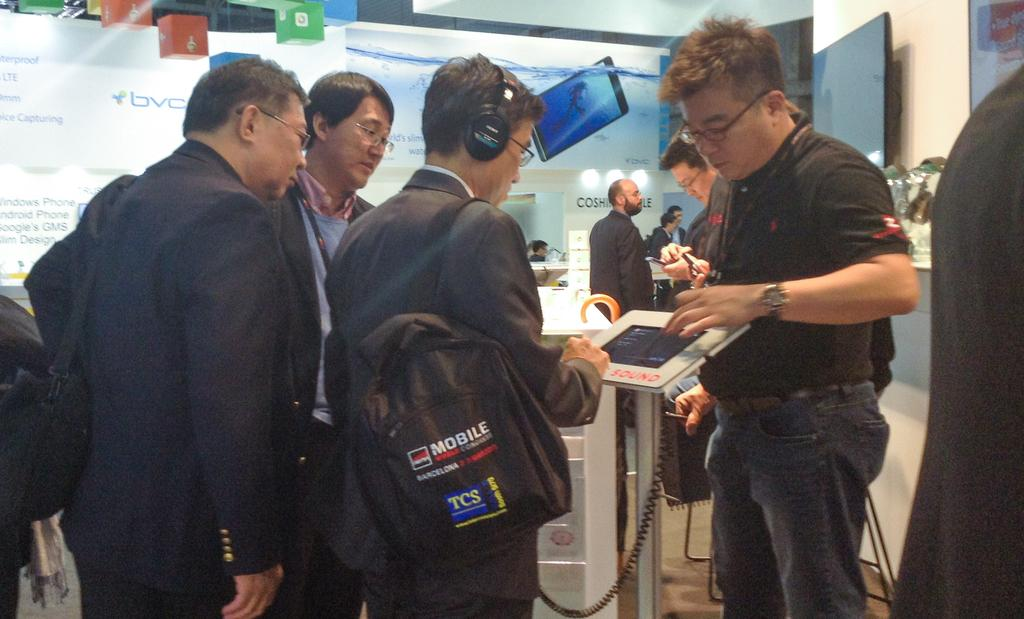What can be observed about the people in the image? There are people standing in the image. What are some people wearing in the image? Some people are wearing bags in the image. What objects can be seen in the image besides people? There are boards, banners, and a screen in the image. What is the background of the image like? There is a white wall in the image. Can you tell me how many arches are present in the image? There are no arches present in the image. What type of event is taking place in the image? The image does not provide enough information to determine if an event is taking place or what type of event it might be. 